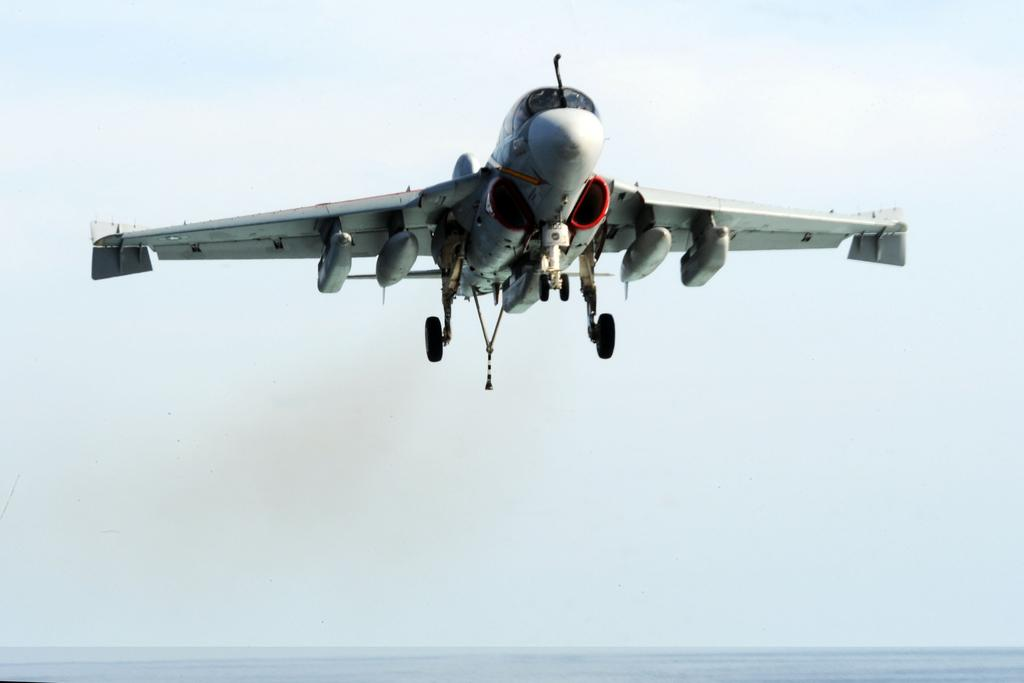What is the main subject of the image? The main subject of the image is an airplane. What is the airplane doing in the image? The airplane is flying in the air. What color is the background of the image? The background of the image is white. What can be seen at the bottom of the image? There is water visible at the bottom of the image. What type of neck ornament is the airplane wearing in the image? There is no neck ornament present on the airplane in the image. Can you describe the clouds visible in the image? There are no clouds visible in the image; the background is white. 